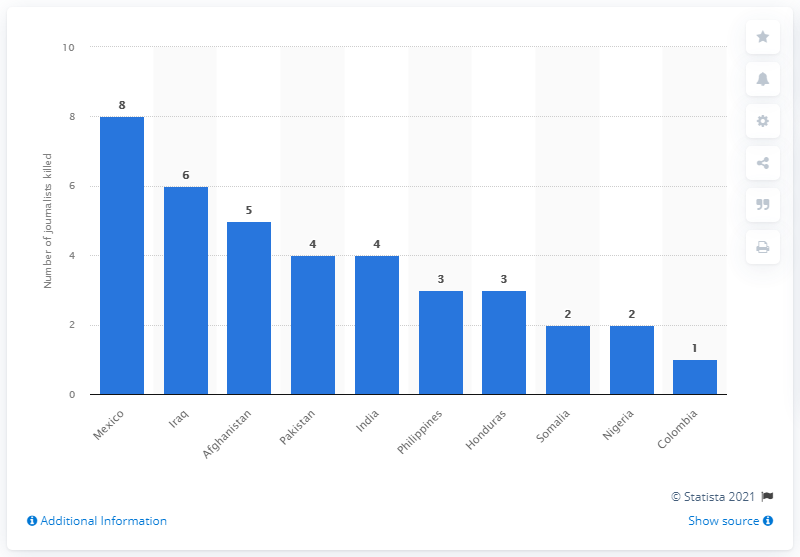Outline some significant characteristics in this image. Afghanistan was declared the least dangerous country for journalists in 2020. 